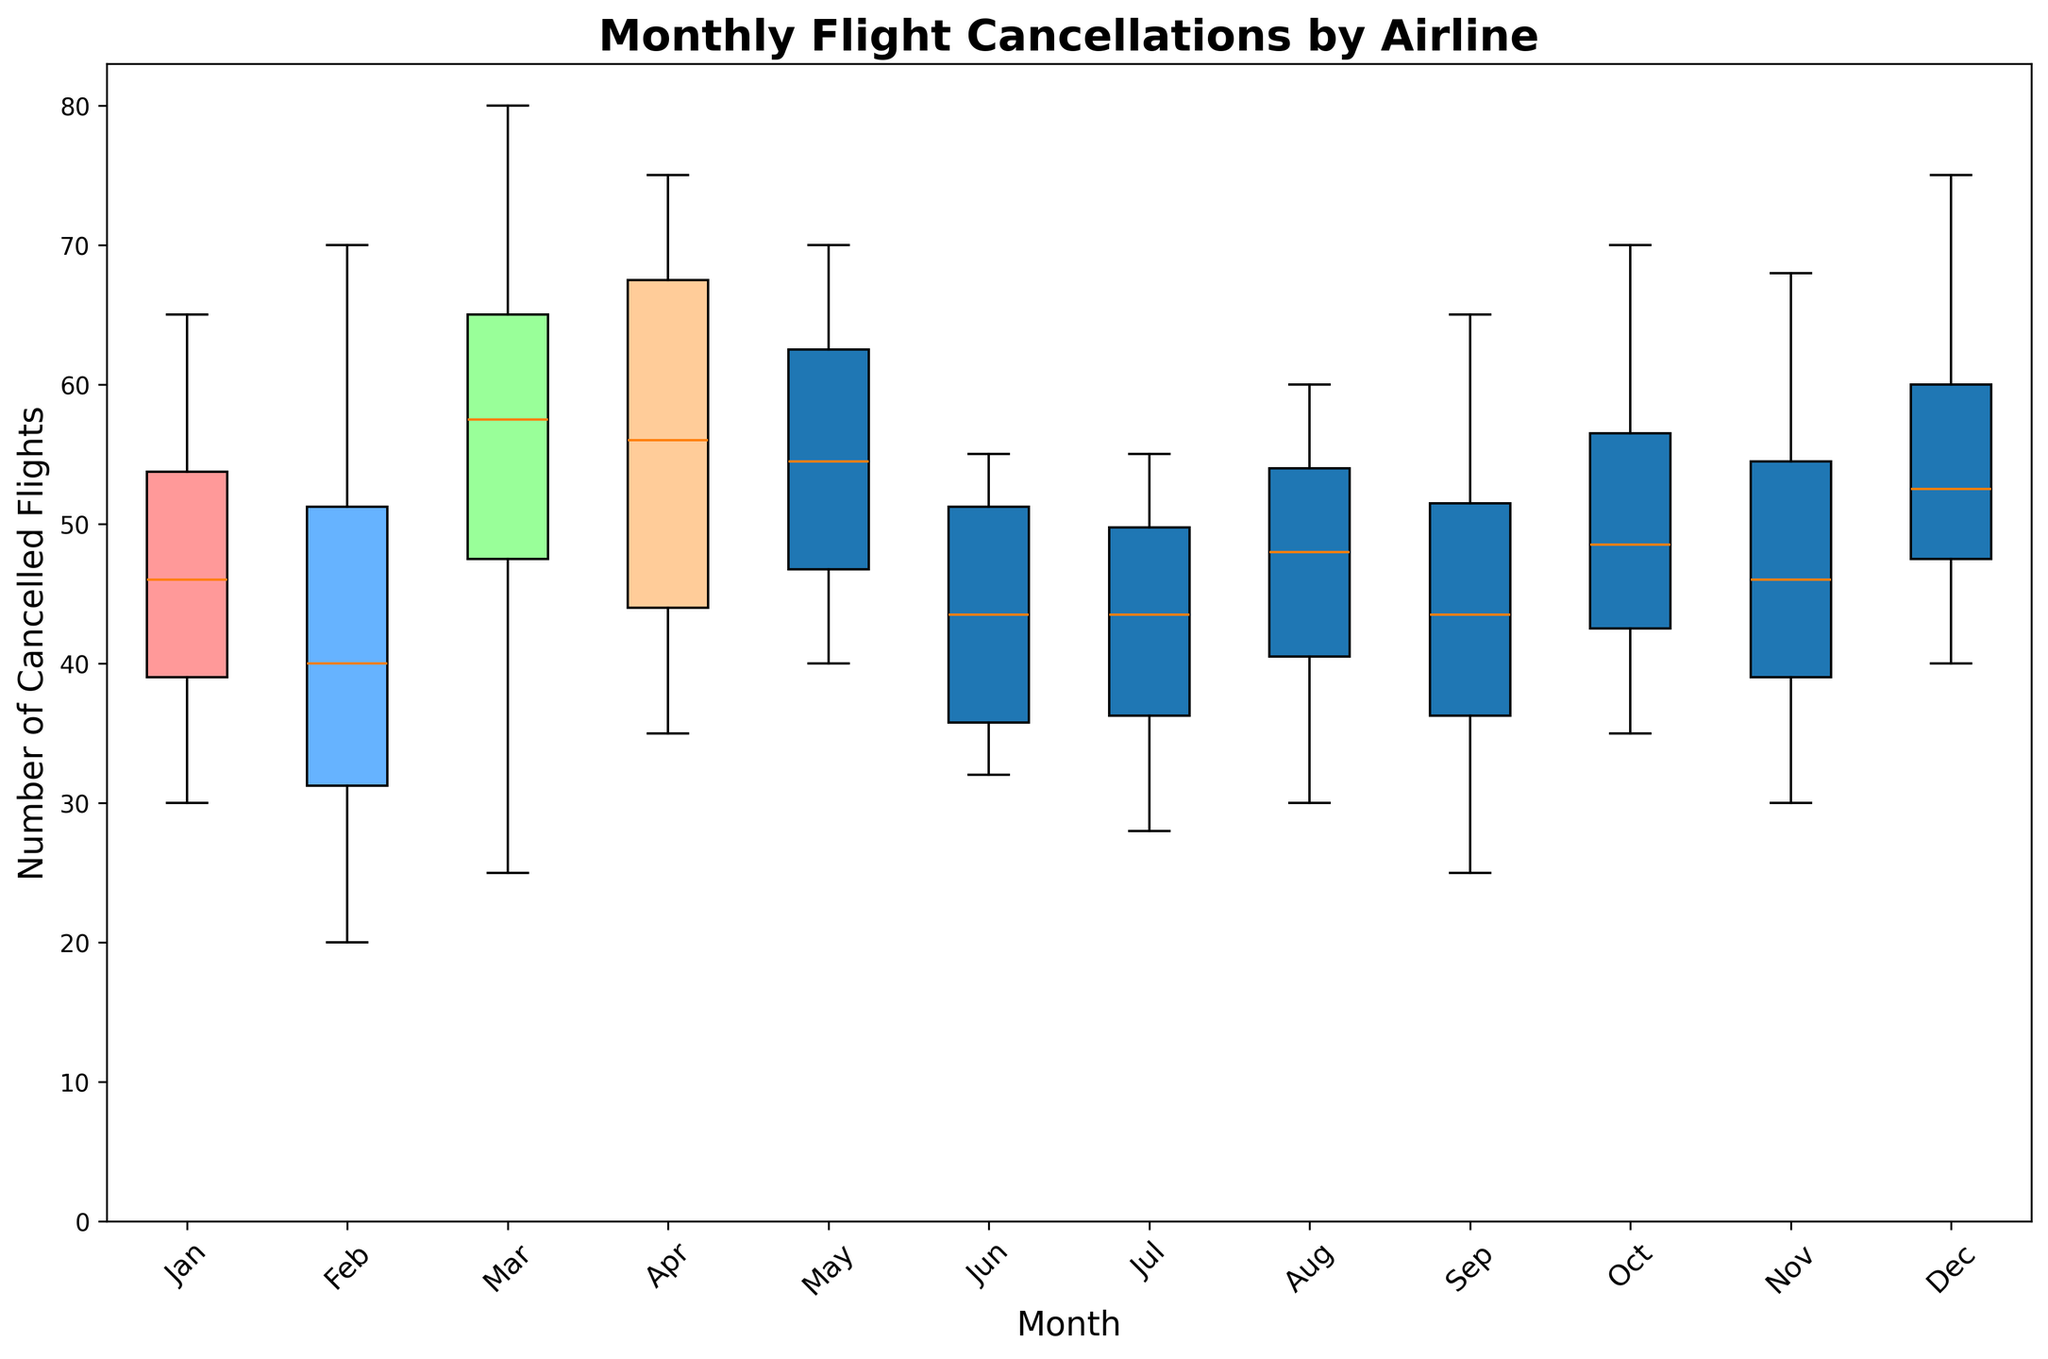What's the median number of cancelled flights in June? To determine the median number of cancelled flights in June, we look at the June data points for all airlines. These are 55, 37, 50, and 32. The median is the middle value of the ordered list, which is (32, 37, 50, 55). Since there are four values, the median is the average of the two middle values: (37 + 50) / 2 = 43.5.
Answer: 43.5 Which month shows the highest range in the number of cancelled flights? To determine the month with the highest range in cancelled flights, we calculate the difference between the maximum and minimum cancelled flights for each month. For example, in January, the range is 65 - 30 = 35. Perform this for all months and find the month with the maximum range. From the data, March has the highest range: 80 - 25 = 55.
Answer: March Which airline appears to have the most consistent cancellation rates across the months? Consistency can be gauged by looking at the spread of the data points for each airline. If Airline D consistently has points with less variance (closer together) in each month's boxplot compared to the other airlines, then Airline D is the most consistent. Visually verifying the boxplot, we see that Airline D consistently shows the least spread in cancelled flights across all months.
Answer: Airline D What is the interquartile range (IQR) for cancelled flights in July? For July, we collect the data points: 48, 39, 55, 28. The IQR is the difference between the 75th percentile and the 25th percentile. After ordering the data: (28, 39, 48, 55), the 25th percentile (Q1) is 39, and the 75th percentile (Q3) is 48. The IQR is 48 - 39 = 9.
Answer: 9 In which month does Airline C have the highest number of cancellations, and what is that number? We check each month for Airline C’s data to find the maximum number. Reviewing the data, Airline C has the highest number of cancellations in March with 80 flights.
Answer: March, 80 Does any month show an outlier in cancelled flights, and if so, which month and value? Outliers in boxplots are shown as individual points outside the whiskers. Visually observing, September and March appear to have distinct outliers. For example, in March the data point of 80 appears as an outlier.
Answer: March, 80 Based on the colors, how many airlines' cancellation distributions are visually represented? Each airline is represented with a unique color for their boxes. Counting the different colors in the boxplot, four distinct colors are mapped to four airlines.
Answer: 4 